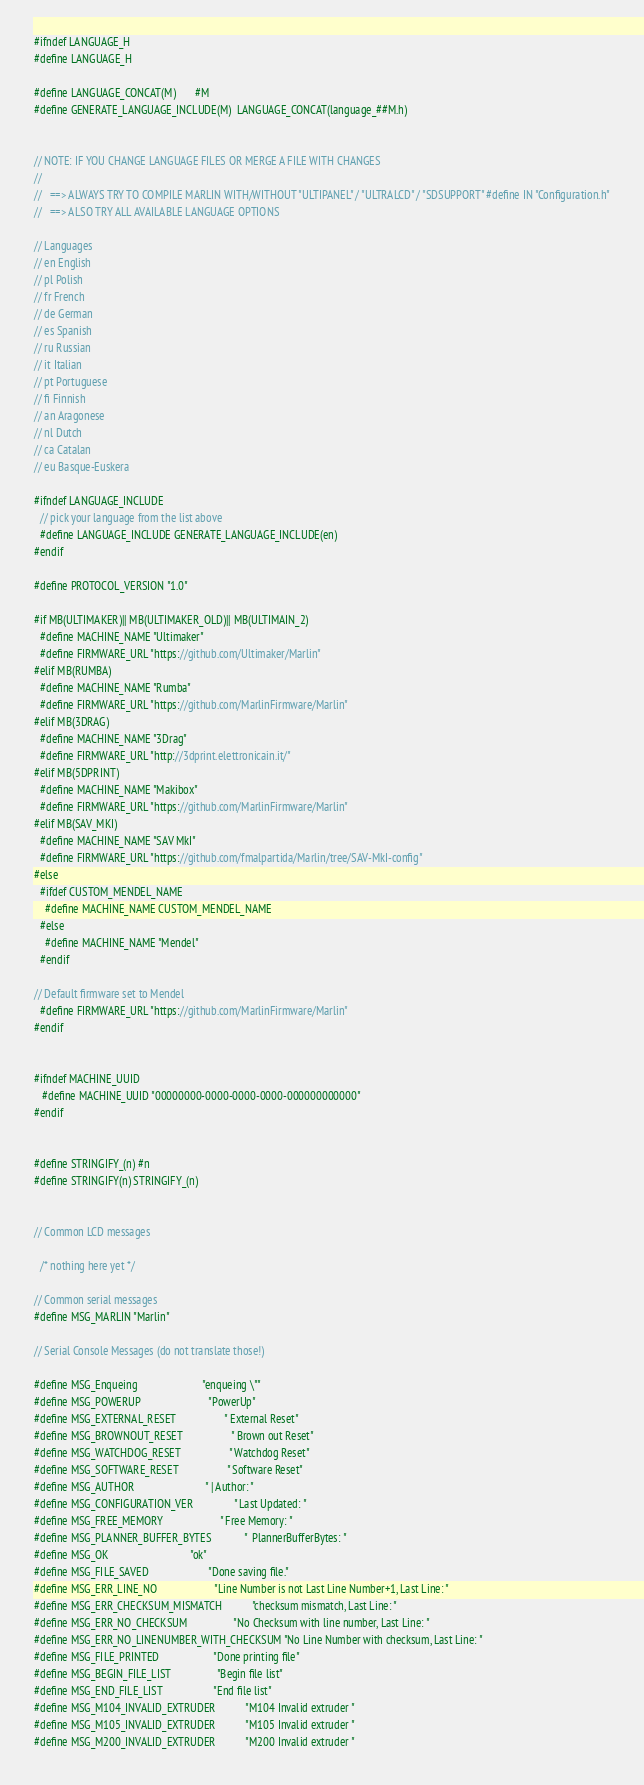Convert code to text. <code><loc_0><loc_0><loc_500><loc_500><_C_>#ifndef LANGUAGE_H
#define LANGUAGE_H

#define LANGUAGE_CONCAT(M)       #M
#define GENERATE_LANGUAGE_INCLUDE(M)  LANGUAGE_CONCAT(language_##M.h)


// NOTE: IF YOU CHANGE LANGUAGE FILES OR MERGE A FILE WITH CHANGES
//
//   ==> ALWAYS TRY TO COMPILE MARLIN WITH/WITHOUT "ULTIPANEL" / "ULTRALCD" / "SDSUPPORT" #define IN "Configuration.h"
//   ==> ALSO TRY ALL AVAILABLE LANGUAGE OPTIONS

// Languages
// en English
// pl Polish
// fr French
// de German
// es Spanish
// ru Russian
// it Italian
// pt Portuguese
// fi Finnish
// an Aragonese
// nl Dutch
// ca Catalan
// eu Basque-Euskera

#ifndef LANGUAGE_INCLUDE
  // pick your language from the list above
  #define LANGUAGE_INCLUDE GENERATE_LANGUAGE_INCLUDE(en)
#endif

#define PROTOCOL_VERSION "1.0"

#if MB(ULTIMAKER)|| MB(ULTIMAKER_OLD)|| MB(ULTIMAIN_2)
  #define MACHINE_NAME "Ultimaker"
  #define FIRMWARE_URL "https://github.com/Ultimaker/Marlin"
#elif MB(RUMBA)
  #define MACHINE_NAME "Rumba"
  #define FIRMWARE_URL "https://github.com/MarlinFirmware/Marlin"
#elif MB(3DRAG)
  #define MACHINE_NAME "3Drag"
  #define FIRMWARE_URL "http://3dprint.elettronicain.it/"
#elif MB(5DPRINT)
  #define MACHINE_NAME "Makibox"
  #define FIRMWARE_URL "https://github.com/MarlinFirmware/Marlin"
#elif MB(SAV_MKI)
  #define MACHINE_NAME "SAV MkI"
  #define FIRMWARE_URL "https://github.com/fmalpartida/Marlin/tree/SAV-MkI-config"
#else
  #ifdef CUSTOM_MENDEL_NAME
    #define MACHINE_NAME CUSTOM_MENDEL_NAME
  #else
    #define MACHINE_NAME "Mendel"
  #endif

// Default firmware set to Mendel
  #define FIRMWARE_URL "https://github.com/MarlinFirmware/Marlin"
#endif


#ifndef MACHINE_UUID
   #define MACHINE_UUID "00000000-0000-0000-0000-000000000000"
#endif


#define STRINGIFY_(n) #n
#define STRINGIFY(n) STRINGIFY_(n)


// Common LCD messages

  /* nothing here yet */

// Common serial messages
#define MSG_MARLIN "Marlin"

// Serial Console Messages (do not translate those!)

#define MSG_Enqueing                        "enqueing \""
#define MSG_POWERUP                         "PowerUp"
#define MSG_EXTERNAL_RESET                  " External Reset"
#define MSG_BROWNOUT_RESET                  " Brown out Reset"
#define MSG_WATCHDOG_RESET                  " Watchdog Reset"
#define MSG_SOFTWARE_RESET                  " Software Reset"
#define MSG_AUTHOR                          " | Author: "
#define MSG_CONFIGURATION_VER               " Last Updated: "
#define MSG_FREE_MEMORY                     " Free Memory: "
#define MSG_PLANNER_BUFFER_BYTES            "  PlannerBufferBytes: "
#define MSG_OK                              "ok"
#define MSG_FILE_SAVED                      "Done saving file."
#define MSG_ERR_LINE_NO                     "Line Number is not Last Line Number+1, Last Line: "
#define MSG_ERR_CHECKSUM_MISMATCH           "checksum mismatch, Last Line: "
#define MSG_ERR_NO_CHECKSUM                 "No Checksum with line number, Last Line: "
#define MSG_ERR_NO_LINENUMBER_WITH_CHECKSUM "No Line Number with checksum, Last Line: "
#define MSG_FILE_PRINTED                    "Done printing file"
#define MSG_BEGIN_FILE_LIST                 "Begin file list"
#define MSG_END_FILE_LIST                   "End file list"
#define MSG_M104_INVALID_EXTRUDER           "M104 Invalid extruder "
#define MSG_M105_INVALID_EXTRUDER           "M105 Invalid extruder "
#define MSG_M200_INVALID_EXTRUDER           "M200 Invalid extruder "</code> 